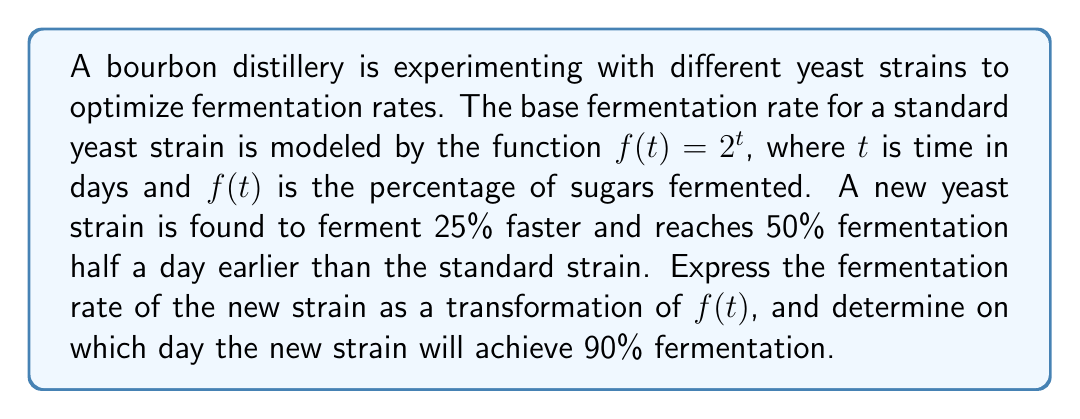Can you answer this question? 1. Let's denote the new fermentation rate function as $g(t)$.

2. The new strain ferments 25% faster, so we need to stretch the function horizontally by a factor of $\frac{1}{1.25} = 0.8$:
   $g(t) = f(0.8t)$

3. The new strain reaches 50% fermentation half a day earlier. This means we need to shift the function left by 0.5 days:
   $g(t) = f(0.8(t+0.5))$

4. Now we have our transformed function: $g(t) = 2^{0.8(t+0.5)}$

5. To find when 90% fermentation is achieved, we solve:
   $90 = 2^{0.8(t+0.5)}$

6. Taking logarithms of both sides (base 2):
   $\log_2(90) = 0.8(t+0.5)$

7. Solving for $t$:
   $t = \frac{\log_2(90)}{0.8} - 0.5$

8. Calculate the result:
   $t \approx 7.4532 - 0.5 = 6.9532$

9. Since we're working with days, we round up to the nearest whole day.
Answer: $g(t) = 2^{0.8(t+0.5)}$; 7 days 